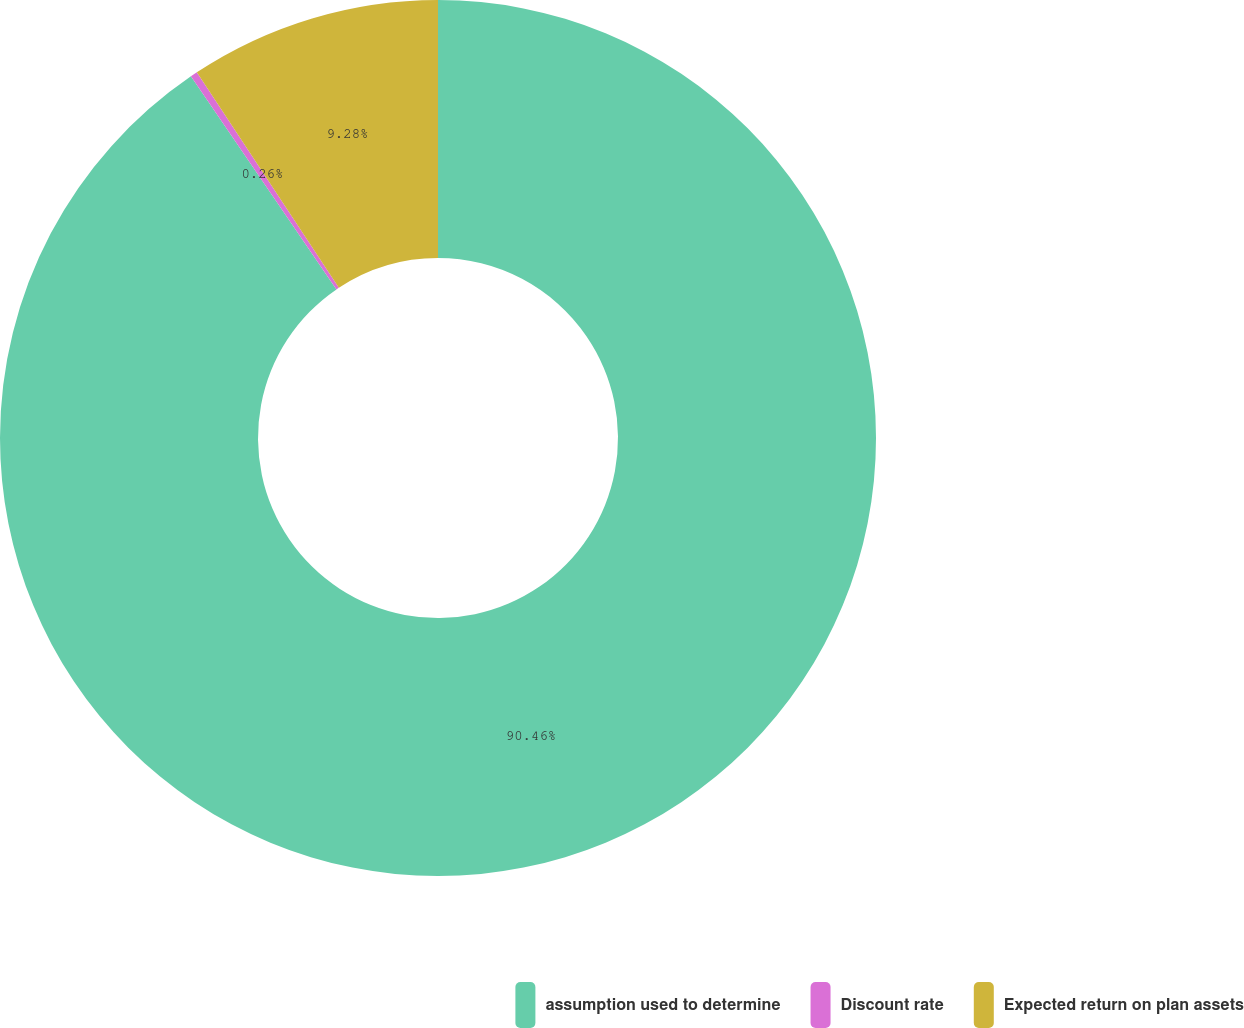Convert chart. <chart><loc_0><loc_0><loc_500><loc_500><pie_chart><fcel>assumption used to determine<fcel>Discount rate<fcel>Expected return on plan assets<nl><fcel>90.46%<fcel>0.26%<fcel>9.28%<nl></chart> 